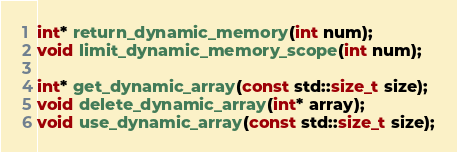<code> <loc_0><loc_0><loc_500><loc_500><_C_>int* return_dynamic_memory(int num);
void limit_dynamic_memory_scope(int num);

int* get_dynamic_array(const std::size_t size);
void delete_dynamic_array(int* array);
void use_dynamic_array(const std::size_t size);</code> 